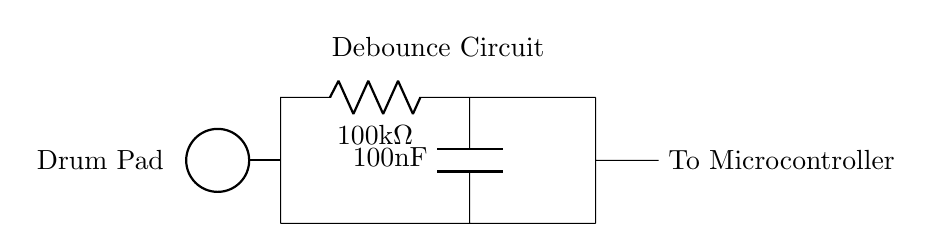What type of components are in the circuit? The circuit consists of a resistor and a capacitor, identified clearly in the diagram as R and C components.
Answer: Resistor and Capacitor What is the resistance value of R1? The resistance value of R1 is given directly next to the component label, which is 100 kΩ.
Answer: 100 kΩ What is the capacitance value of C1? The capacitance value of C1 is provided next to the component label, which is 100 nF.
Answer: 100 nF How does the capacitor affect the drum pad input signal? The capacitor temporarily stores charge and thereby filters out noise, allowing for smoother transitions of the drum pad signal to the microcontroller.
Answer: It filters noise What is the main function of this debounce circuit? The debounce circuit's primary function is to eliminate unwanted noise and ensure that only a single signal transition is sent to the microcontroller each time the drum pad is struck.
Answer: Eliminates noise What will happen if the resistor value is increased? Increasing the resistor value will increase the time constant of the RC circuit, making the debounce effect longer, which may delay signal detection.
Answer: Debounce time increases 